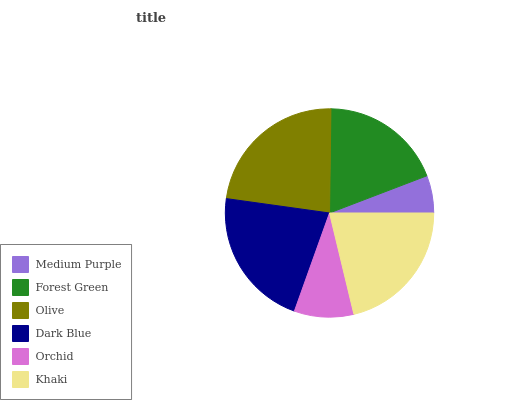Is Medium Purple the minimum?
Answer yes or no. Yes. Is Olive the maximum?
Answer yes or no. Yes. Is Forest Green the minimum?
Answer yes or no. No. Is Forest Green the maximum?
Answer yes or no. No. Is Forest Green greater than Medium Purple?
Answer yes or no. Yes. Is Medium Purple less than Forest Green?
Answer yes or no. Yes. Is Medium Purple greater than Forest Green?
Answer yes or no. No. Is Forest Green less than Medium Purple?
Answer yes or no. No. Is Khaki the high median?
Answer yes or no. Yes. Is Forest Green the low median?
Answer yes or no. Yes. Is Orchid the high median?
Answer yes or no. No. Is Medium Purple the low median?
Answer yes or no. No. 